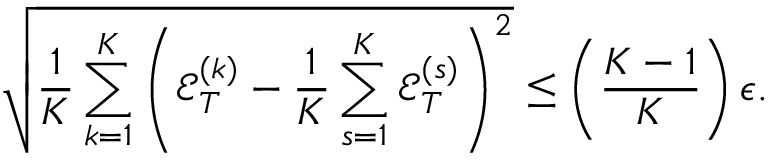Convert formula to latex. <formula><loc_0><loc_0><loc_500><loc_500>\sqrt { \frac { 1 } { K } \sum _ { k = 1 } ^ { K } \left ( { \mathcal { E } } _ { T } ^ { ( k ) } - \frac { 1 } { K } \sum _ { s = 1 } ^ { K } { \mathcal { E } } _ { T } ^ { ( s ) } \right ) ^ { 2 } } \leq \left ( \frac { K - 1 } { K } \right ) \epsilon .</formula> 